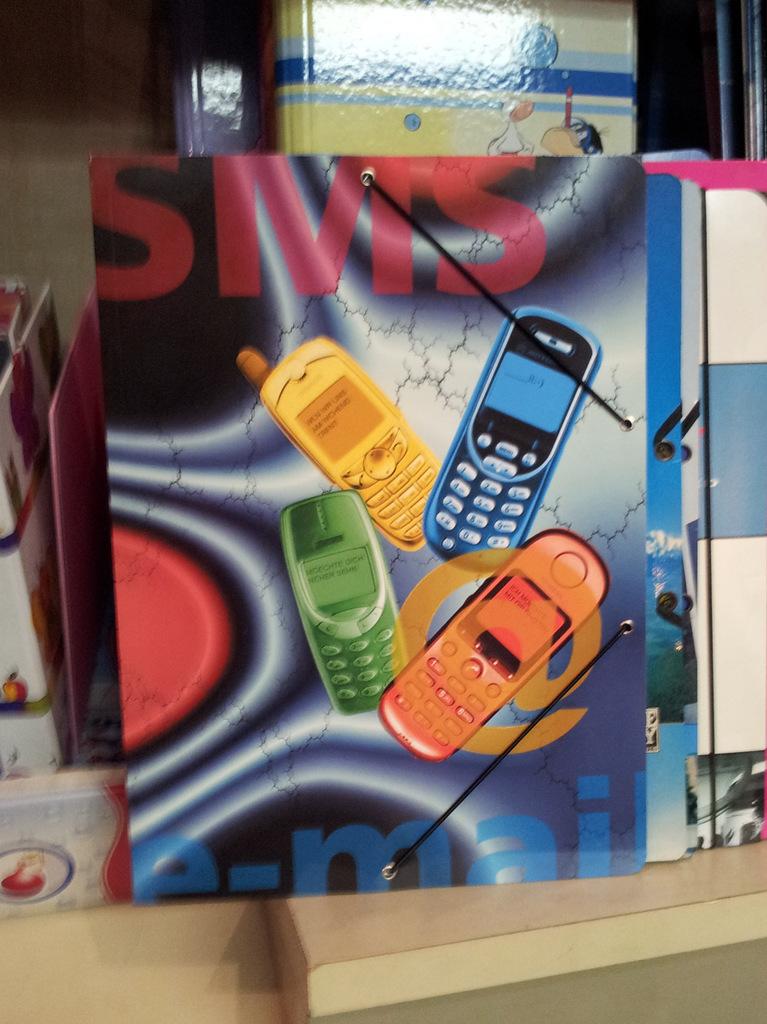How many phones are there?
Offer a very short reply. Answering does not require reading text in the image. 